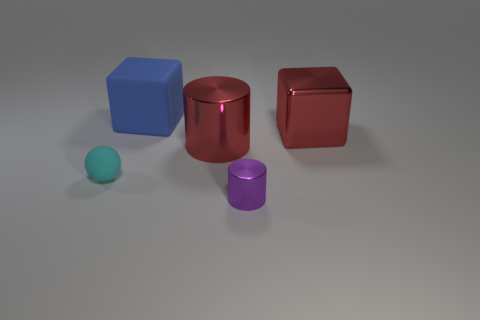Is the color of the large shiny cylinder the same as the metal block?
Your answer should be compact. Yes. How many things are both on the left side of the big shiny cylinder and behind the large red cylinder?
Keep it short and to the point. 1. There is a tiny cyan object that is the same material as the blue object; what shape is it?
Make the answer very short. Sphere. Does the block that is in front of the large blue object have the same size as the shiny cylinder behind the small purple metal object?
Give a very brief answer. Yes. What is the color of the metallic object on the left side of the tiny purple metal object?
Provide a short and direct response. Red. There is a small thing on the left side of the matte object behind the rubber ball; what is its material?
Your answer should be very brief. Rubber. The large matte thing has what shape?
Offer a very short reply. Cube. There is another thing that is the same shape as the blue thing; what material is it?
Offer a very short reply. Metal. How many metal cylinders have the same size as the cyan rubber thing?
Keep it short and to the point. 1. Are there any objects that are right of the cyan sphere to the left of the small purple object?
Your response must be concise. Yes. 